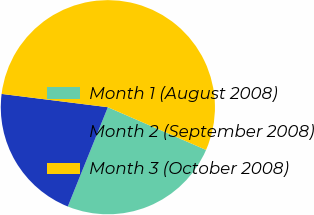Convert chart. <chart><loc_0><loc_0><loc_500><loc_500><pie_chart><fcel>Month 1 (August 2008)<fcel>Month 2 (September 2008)<fcel>Month 3 (October 2008)<nl><fcel>24.57%<fcel>20.88%<fcel>54.55%<nl></chart> 